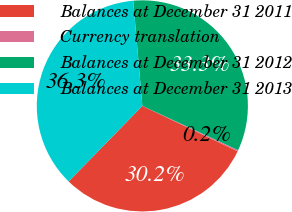<chart> <loc_0><loc_0><loc_500><loc_500><pie_chart><fcel>Balances at December 31 2011<fcel>Currency translation<fcel>Balances at December 31 2012<fcel>Balances at December 31 2013<nl><fcel>30.22%<fcel>0.19%<fcel>33.27%<fcel>36.32%<nl></chart> 